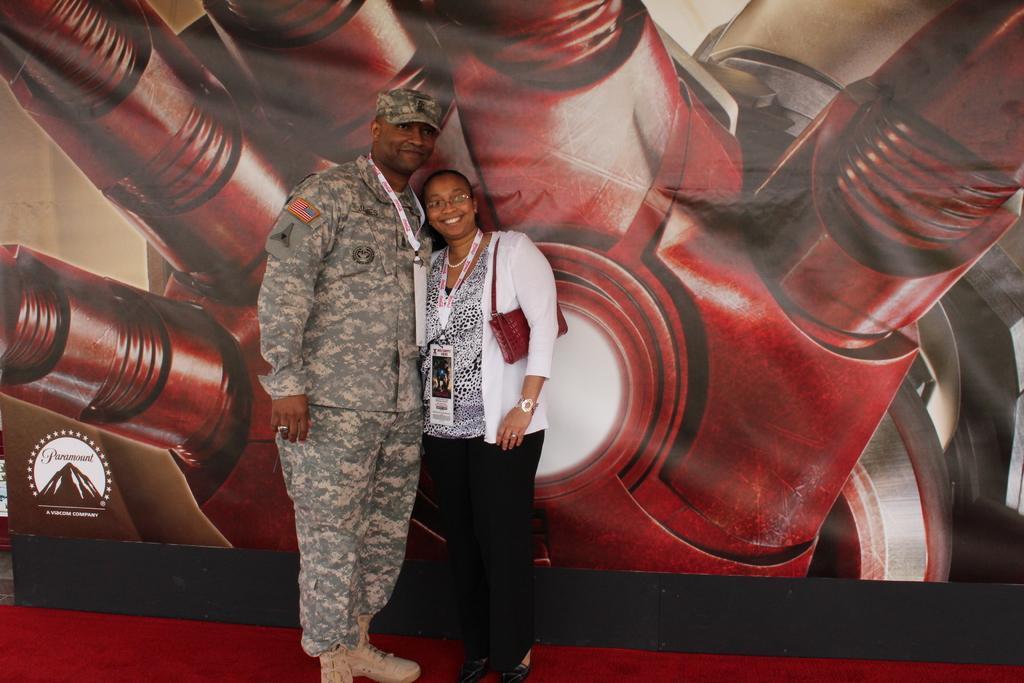Could you give a brief overview of what you see in this image? In the image we can see there are people standing and they are wearing id cards in their neck. Behind there is a banner. 